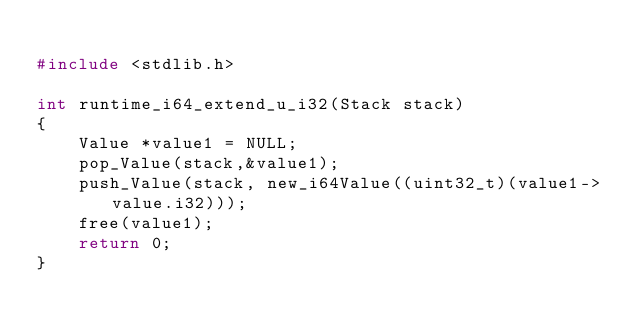<code> <loc_0><loc_0><loc_500><loc_500><_C_>
#include <stdlib.h>

int runtime_i64_extend_u_i32(Stack stack)
{
    Value *value1 = NULL;
    pop_Value(stack,&value1);
    push_Value(stack, new_i64Value((uint32_t)(value1->value.i32)));
    free(value1);
    return 0;
}
</code> 